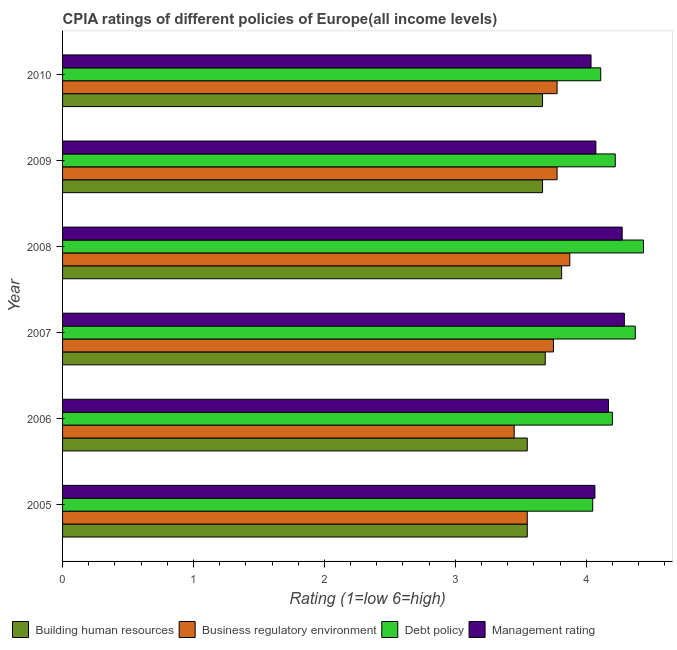How many groups of bars are there?
Offer a very short reply. 6. Are the number of bars per tick equal to the number of legend labels?
Make the answer very short. Yes. Are the number of bars on each tick of the Y-axis equal?
Your response must be concise. Yes. How many bars are there on the 5th tick from the top?
Ensure brevity in your answer.  4. How many bars are there on the 5th tick from the bottom?
Keep it short and to the point. 4. In how many cases, is the number of bars for a given year not equal to the number of legend labels?
Provide a succinct answer. 0. What is the cpia rating of debt policy in 2007?
Give a very brief answer. 4.38. Across all years, what is the maximum cpia rating of debt policy?
Make the answer very short. 4.44. Across all years, what is the minimum cpia rating of debt policy?
Keep it short and to the point. 4.05. In which year was the cpia rating of management maximum?
Provide a succinct answer. 2007. In which year was the cpia rating of management minimum?
Your answer should be very brief. 2010. What is the total cpia rating of building human resources in the graph?
Keep it short and to the point. 21.93. What is the difference between the cpia rating of debt policy in 2006 and that in 2008?
Provide a succinct answer. -0.24. What is the difference between the cpia rating of business regulatory environment in 2007 and the cpia rating of building human resources in 2005?
Give a very brief answer. 0.2. What is the average cpia rating of business regulatory environment per year?
Keep it short and to the point. 3.7. What is the ratio of the cpia rating of debt policy in 2006 to that in 2008?
Provide a short and direct response. 0.95. Is the cpia rating of debt policy in 2006 less than that in 2007?
Provide a succinct answer. Yes. Is the difference between the cpia rating of debt policy in 2005 and 2008 greater than the difference between the cpia rating of building human resources in 2005 and 2008?
Ensure brevity in your answer.  No. What is the difference between the highest and the second highest cpia rating of management?
Provide a short and direct response. 0.02. What is the difference between the highest and the lowest cpia rating of business regulatory environment?
Your answer should be compact. 0.42. In how many years, is the cpia rating of business regulatory environment greater than the average cpia rating of business regulatory environment taken over all years?
Offer a very short reply. 4. Is the sum of the cpia rating of management in 2007 and 2009 greater than the maximum cpia rating of debt policy across all years?
Offer a very short reply. Yes. What does the 2nd bar from the top in 2006 represents?
Keep it short and to the point. Debt policy. What does the 1st bar from the bottom in 2005 represents?
Ensure brevity in your answer.  Building human resources. Is it the case that in every year, the sum of the cpia rating of building human resources and cpia rating of business regulatory environment is greater than the cpia rating of debt policy?
Give a very brief answer. Yes. Are all the bars in the graph horizontal?
Make the answer very short. Yes. How many years are there in the graph?
Ensure brevity in your answer.  6. What is the title of the graph?
Provide a succinct answer. CPIA ratings of different policies of Europe(all income levels). Does "Austria" appear as one of the legend labels in the graph?
Make the answer very short. No. What is the label or title of the X-axis?
Give a very brief answer. Rating (1=low 6=high). What is the label or title of the Y-axis?
Provide a succinct answer. Year. What is the Rating (1=low 6=high) in Building human resources in 2005?
Ensure brevity in your answer.  3.55. What is the Rating (1=low 6=high) in Business regulatory environment in 2005?
Your answer should be very brief. 3.55. What is the Rating (1=low 6=high) of Debt policy in 2005?
Offer a very short reply. 4.05. What is the Rating (1=low 6=high) in Management rating in 2005?
Your response must be concise. 4.07. What is the Rating (1=low 6=high) in Building human resources in 2006?
Your answer should be very brief. 3.55. What is the Rating (1=low 6=high) of Business regulatory environment in 2006?
Offer a terse response. 3.45. What is the Rating (1=low 6=high) in Debt policy in 2006?
Give a very brief answer. 4.2. What is the Rating (1=low 6=high) of Management rating in 2006?
Provide a succinct answer. 4.17. What is the Rating (1=low 6=high) of Building human resources in 2007?
Provide a succinct answer. 3.69. What is the Rating (1=low 6=high) of Business regulatory environment in 2007?
Ensure brevity in your answer.  3.75. What is the Rating (1=low 6=high) of Debt policy in 2007?
Give a very brief answer. 4.38. What is the Rating (1=low 6=high) in Management rating in 2007?
Offer a terse response. 4.29. What is the Rating (1=low 6=high) in Building human resources in 2008?
Ensure brevity in your answer.  3.81. What is the Rating (1=low 6=high) in Business regulatory environment in 2008?
Offer a very short reply. 3.88. What is the Rating (1=low 6=high) in Debt policy in 2008?
Your response must be concise. 4.44. What is the Rating (1=low 6=high) of Management rating in 2008?
Your answer should be compact. 4.28. What is the Rating (1=low 6=high) of Building human resources in 2009?
Keep it short and to the point. 3.67. What is the Rating (1=low 6=high) of Business regulatory environment in 2009?
Offer a terse response. 3.78. What is the Rating (1=low 6=high) in Debt policy in 2009?
Provide a succinct answer. 4.22. What is the Rating (1=low 6=high) in Management rating in 2009?
Give a very brief answer. 4.07. What is the Rating (1=low 6=high) of Building human resources in 2010?
Your answer should be very brief. 3.67. What is the Rating (1=low 6=high) in Business regulatory environment in 2010?
Keep it short and to the point. 3.78. What is the Rating (1=low 6=high) of Debt policy in 2010?
Your answer should be very brief. 4.11. What is the Rating (1=low 6=high) in Management rating in 2010?
Your answer should be compact. 4.04. Across all years, what is the maximum Rating (1=low 6=high) of Building human resources?
Offer a very short reply. 3.81. Across all years, what is the maximum Rating (1=low 6=high) in Business regulatory environment?
Make the answer very short. 3.88. Across all years, what is the maximum Rating (1=low 6=high) in Debt policy?
Offer a terse response. 4.44. Across all years, what is the maximum Rating (1=low 6=high) in Management rating?
Offer a terse response. 4.29. Across all years, what is the minimum Rating (1=low 6=high) in Building human resources?
Give a very brief answer. 3.55. Across all years, what is the minimum Rating (1=low 6=high) in Business regulatory environment?
Keep it short and to the point. 3.45. Across all years, what is the minimum Rating (1=low 6=high) in Debt policy?
Make the answer very short. 4.05. Across all years, what is the minimum Rating (1=low 6=high) in Management rating?
Ensure brevity in your answer.  4.04. What is the total Rating (1=low 6=high) of Building human resources in the graph?
Provide a succinct answer. 21.93. What is the total Rating (1=low 6=high) in Business regulatory environment in the graph?
Your response must be concise. 22.18. What is the total Rating (1=low 6=high) in Debt policy in the graph?
Your answer should be very brief. 25.4. What is the total Rating (1=low 6=high) of Management rating in the graph?
Give a very brief answer. 24.91. What is the difference between the Rating (1=low 6=high) in Building human resources in 2005 and that in 2006?
Your response must be concise. 0. What is the difference between the Rating (1=low 6=high) of Business regulatory environment in 2005 and that in 2006?
Give a very brief answer. 0.1. What is the difference between the Rating (1=low 6=high) in Debt policy in 2005 and that in 2006?
Provide a short and direct response. -0.15. What is the difference between the Rating (1=low 6=high) in Management rating in 2005 and that in 2006?
Your answer should be very brief. -0.1. What is the difference between the Rating (1=low 6=high) of Building human resources in 2005 and that in 2007?
Offer a terse response. -0.14. What is the difference between the Rating (1=low 6=high) of Business regulatory environment in 2005 and that in 2007?
Provide a succinct answer. -0.2. What is the difference between the Rating (1=low 6=high) of Debt policy in 2005 and that in 2007?
Provide a short and direct response. -0.33. What is the difference between the Rating (1=low 6=high) of Management rating in 2005 and that in 2007?
Offer a very short reply. -0.23. What is the difference between the Rating (1=low 6=high) in Building human resources in 2005 and that in 2008?
Ensure brevity in your answer.  -0.26. What is the difference between the Rating (1=low 6=high) of Business regulatory environment in 2005 and that in 2008?
Ensure brevity in your answer.  -0.33. What is the difference between the Rating (1=low 6=high) of Debt policy in 2005 and that in 2008?
Make the answer very short. -0.39. What is the difference between the Rating (1=low 6=high) of Management rating in 2005 and that in 2008?
Keep it short and to the point. -0.21. What is the difference between the Rating (1=low 6=high) of Building human resources in 2005 and that in 2009?
Offer a very short reply. -0.12. What is the difference between the Rating (1=low 6=high) in Business regulatory environment in 2005 and that in 2009?
Keep it short and to the point. -0.23. What is the difference between the Rating (1=low 6=high) of Debt policy in 2005 and that in 2009?
Your answer should be very brief. -0.17. What is the difference between the Rating (1=low 6=high) in Management rating in 2005 and that in 2009?
Offer a very short reply. -0.01. What is the difference between the Rating (1=low 6=high) in Building human resources in 2005 and that in 2010?
Make the answer very short. -0.12. What is the difference between the Rating (1=low 6=high) in Business regulatory environment in 2005 and that in 2010?
Give a very brief answer. -0.23. What is the difference between the Rating (1=low 6=high) of Debt policy in 2005 and that in 2010?
Make the answer very short. -0.06. What is the difference between the Rating (1=low 6=high) in Management rating in 2005 and that in 2010?
Provide a short and direct response. 0.03. What is the difference between the Rating (1=low 6=high) in Building human resources in 2006 and that in 2007?
Your answer should be compact. -0.14. What is the difference between the Rating (1=low 6=high) in Debt policy in 2006 and that in 2007?
Provide a succinct answer. -0.17. What is the difference between the Rating (1=low 6=high) of Management rating in 2006 and that in 2007?
Your answer should be very brief. -0.12. What is the difference between the Rating (1=low 6=high) in Building human resources in 2006 and that in 2008?
Offer a very short reply. -0.26. What is the difference between the Rating (1=low 6=high) of Business regulatory environment in 2006 and that in 2008?
Make the answer very short. -0.42. What is the difference between the Rating (1=low 6=high) of Debt policy in 2006 and that in 2008?
Give a very brief answer. -0.24. What is the difference between the Rating (1=low 6=high) of Management rating in 2006 and that in 2008?
Keep it short and to the point. -0.1. What is the difference between the Rating (1=low 6=high) of Building human resources in 2006 and that in 2009?
Ensure brevity in your answer.  -0.12. What is the difference between the Rating (1=low 6=high) of Business regulatory environment in 2006 and that in 2009?
Give a very brief answer. -0.33. What is the difference between the Rating (1=low 6=high) of Debt policy in 2006 and that in 2009?
Your answer should be very brief. -0.02. What is the difference between the Rating (1=low 6=high) of Management rating in 2006 and that in 2009?
Give a very brief answer. 0.1. What is the difference between the Rating (1=low 6=high) in Building human resources in 2006 and that in 2010?
Offer a very short reply. -0.12. What is the difference between the Rating (1=low 6=high) in Business regulatory environment in 2006 and that in 2010?
Provide a short and direct response. -0.33. What is the difference between the Rating (1=low 6=high) in Debt policy in 2006 and that in 2010?
Provide a succinct answer. 0.09. What is the difference between the Rating (1=low 6=high) of Management rating in 2006 and that in 2010?
Offer a very short reply. 0.13. What is the difference between the Rating (1=low 6=high) of Building human resources in 2007 and that in 2008?
Provide a succinct answer. -0.12. What is the difference between the Rating (1=low 6=high) of Business regulatory environment in 2007 and that in 2008?
Provide a succinct answer. -0.12. What is the difference between the Rating (1=low 6=high) in Debt policy in 2007 and that in 2008?
Make the answer very short. -0.06. What is the difference between the Rating (1=low 6=high) of Management rating in 2007 and that in 2008?
Keep it short and to the point. 0.02. What is the difference between the Rating (1=low 6=high) of Building human resources in 2007 and that in 2009?
Provide a succinct answer. 0.02. What is the difference between the Rating (1=low 6=high) in Business regulatory environment in 2007 and that in 2009?
Ensure brevity in your answer.  -0.03. What is the difference between the Rating (1=low 6=high) in Debt policy in 2007 and that in 2009?
Provide a short and direct response. 0.15. What is the difference between the Rating (1=low 6=high) of Management rating in 2007 and that in 2009?
Offer a very short reply. 0.22. What is the difference between the Rating (1=low 6=high) in Building human resources in 2007 and that in 2010?
Your response must be concise. 0.02. What is the difference between the Rating (1=low 6=high) in Business regulatory environment in 2007 and that in 2010?
Make the answer very short. -0.03. What is the difference between the Rating (1=low 6=high) of Debt policy in 2007 and that in 2010?
Your answer should be very brief. 0.26. What is the difference between the Rating (1=low 6=high) of Management rating in 2007 and that in 2010?
Your response must be concise. 0.25. What is the difference between the Rating (1=low 6=high) of Building human resources in 2008 and that in 2009?
Keep it short and to the point. 0.15. What is the difference between the Rating (1=low 6=high) of Business regulatory environment in 2008 and that in 2009?
Your answer should be very brief. 0.1. What is the difference between the Rating (1=low 6=high) of Debt policy in 2008 and that in 2009?
Ensure brevity in your answer.  0.22. What is the difference between the Rating (1=low 6=high) in Management rating in 2008 and that in 2009?
Offer a very short reply. 0.2. What is the difference between the Rating (1=low 6=high) in Building human resources in 2008 and that in 2010?
Your answer should be compact. 0.15. What is the difference between the Rating (1=low 6=high) of Business regulatory environment in 2008 and that in 2010?
Give a very brief answer. 0.1. What is the difference between the Rating (1=low 6=high) of Debt policy in 2008 and that in 2010?
Offer a very short reply. 0.33. What is the difference between the Rating (1=low 6=high) in Management rating in 2008 and that in 2010?
Ensure brevity in your answer.  0.24. What is the difference between the Rating (1=low 6=high) of Building human resources in 2009 and that in 2010?
Ensure brevity in your answer.  0. What is the difference between the Rating (1=low 6=high) of Business regulatory environment in 2009 and that in 2010?
Provide a short and direct response. 0. What is the difference between the Rating (1=low 6=high) in Management rating in 2009 and that in 2010?
Your answer should be compact. 0.04. What is the difference between the Rating (1=low 6=high) of Building human resources in 2005 and the Rating (1=low 6=high) of Business regulatory environment in 2006?
Offer a very short reply. 0.1. What is the difference between the Rating (1=low 6=high) of Building human resources in 2005 and the Rating (1=low 6=high) of Debt policy in 2006?
Give a very brief answer. -0.65. What is the difference between the Rating (1=low 6=high) of Building human resources in 2005 and the Rating (1=low 6=high) of Management rating in 2006?
Your answer should be very brief. -0.62. What is the difference between the Rating (1=low 6=high) of Business regulatory environment in 2005 and the Rating (1=low 6=high) of Debt policy in 2006?
Offer a very short reply. -0.65. What is the difference between the Rating (1=low 6=high) in Business regulatory environment in 2005 and the Rating (1=low 6=high) in Management rating in 2006?
Make the answer very short. -0.62. What is the difference between the Rating (1=low 6=high) in Debt policy in 2005 and the Rating (1=low 6=high) in Management rating in 2006?
Your response must be concise. -0.12. What is the difference between the Rating (1=low 6=high) of Building human resources in 2005 and the Rating (1=low 6=high) of Business regulatory environment in 2007?
Make the answer very short. -0.2. What is the difference between the Rating (1=low 6=high) of Building human resources in 2005 and the Rating (1=low 6=high) of Debt policy in 2007?
Give a very brief answer. -0.82. What is the difference between the Rating (1=low 6=high) in Building human resources in 2005 and the Rating (1=low 6=high) in Management rating in 2007?
Give a very brief answer. -0.74. What is the difference between the Rating (1=low 6=high) of Business regulatory environment in 2005 and the Rating (1=low 6=high) of Debt policy in 2007?
Offer a very short reply. -0.82. What is the difference between the Rating (1=low 6=high) in Business regulatory environment in 2005 and the Rating (1=low 6=high) in Management rating in 2007?
Offer a very short reply. -0.74. What is the difference between the Rating (1=low 6=high) in Debt policy in 2005 and the Rating (1=low 6=high) in Management rating in 2007?
Offer a terse response. -0.24. What is the difference between the Rating (1=low 6=high) in Building human resources in 2005 and the Rating (1=low 6=high) in Business regulatory environment in 2008?
Offer a very short reply. -0.33. What is the difference between the Rating (1=low 6=high) in Building human resources in 2005 and the Rating (1=low 6=high) in Debt policy in 2008?
Your answer should be very brief. -0.89. What is the difference between the Rating (1=low 6=high) in Building human resources in 2005 and the Rating (1=low 6=high) in Management rating in 2008?
Keep it short and to the point. -0.72. What is the difference between the Rating (1=low 6=high) of Business regulatory environment in 2005 and the Rating (1=low 6=high) of Debt policy in 2008?
Offer a very short reply. -0.89. What is the difference between the Rating (1=low 6=high) in Business regulatory environment in 2005 and the Rating (1=low 6=high) in Management rating in 2008?
Your answer should be compact. -0.72. What is the difference between the Rating (1=low 6=high) in Debt policy in 2005 and the Rating (1=low 6=high) in Management rating in 2008?
Your response must be concise. -0.23. What is the difference between the Rating (1=low 6=high) of Building human resources in 2005 and the Rating (1=low 6=high) of Business regulatory environment in 2009?
Make the answer very short. -0.23. What is the difference between the Rating (1=low 6=high) of Building human resources in 2005 and the Rating (1=low 6=high) of Debt policy in 2009?
Give a very brief answer. -0.67. What is the difference between the Rating (1=low 6=high) of Building human resources in 2005 and the Rating (1=low 6=high) of Management rating in 2009?
Give a very brief answer. -0.52. What is the difference between the Rating (1=low 6=high) of Business regulatory environment in 2005 and the Rating (1=low 6=high) of Debt policy in 2009?
Offer a very short reply. -0.67. What is the difference between the Rating (1=low 6=high) in Business regulatory environment in 2005 and the Rating (1=low 6=high) in Management rating in 2009?
Offer a terse response. -0.52. What is the difference between the Rating (1=low 6=high) of Debt policy in 2005 and the Rating (1=low 6=high) of Management rating in 2009?
Ensure brevity in your answer.  -0.02. What is the difference between the Rating (1=low 6=high) in Building human resources in 2005 and the Rating (1=low 6=high) in Business regulatory environment in 2010?
Offer a very short reply. -0.23. What is the difference between the Rating (1=low 6=high) in Building human resources in 2005 and the Rating (1=low 6=high) in Debt policy in 2010?
Give a very brief answer. -0.56. What is the difference between the Rating (1=low 6=high) in Building human resources in 2005 and the Rating (1=low 6=high) in Management rating in 2010?
Give a very brief answer. -0.49. What is the difference between the Rating (1=low 6=high) in Business regulatory environment in 2005 and the Rating (1=low 6=high) in Debt policy in 2010?
Keep it short and to the point. -0.56. What is the difference between the Rating (1=low 6=high) of Business regulatory environment in 2005 and the Rating (1=low 6=high) of Management rating in 2010?
Provide a succinct answer. -0.49. What is the difference between the Rating (1=low 6=high) in Debt policy in 2005 and the Rating (1=low 6=high) in Management rating in 2010?
Your answer should be very brief. 0.01. What is the difference between the Rating (1=low 6=high) of Building human resources in 2006 and the Rating (1=low 6=high) of Business regulatory environment in 2007?
Your answer should be compact. -0.2. What is the difference between the Rating (1=low 6=high) of Building human resources in 2006 and the Rating (1=low 6=high) of Debt policy in 2007?
Your answer should be compact. -0.82. What is the difference between the Rating (1=low 6=high) of Building human resources in 2006 and the Rating (1=low 6=high) of Management rating in 2007?
Ensure brevity in your answer.  -0.74. What is the difference between the Rating (1=low 6=high) in Business regulatory environment in 2006 and the Rating (1=low 6=high) in Debt policy in 2007?
Ensure brevity in your answer.  -0.93. What is the difference between the Rating (1=low 6=high) of Business regulatory environment in 2006 and the Rating (1=low 6=high) of Management rating in 2007?
Offer a very short reply. -0.84. What is the difference between the Rating (1=low 6=high) in Debt policy in 2006 and the Rating (1=low 6=high) in Management rating in 2007?
Provide a succinct answer. -0.09. What is the difference between the Rating (1=low 6=high) of Building human resources in 2006 and the Rating (1=low 6=high) of Business regulatory environment in 2008?
Your answer should be compact. -0.33. What is the difference between the Rating (1=low 6=high) in Building human resources in 2006 and the Rating (1=low 6=high) in Debt policy in 2008?
Your response must be concise. -0.89. What is the difference between the Rating (1=low 6=high) of Building human resources in 2006 and the Rating (1=low 6=high) of Management rating in 2008?
Your answer should be compact. -0.72. What is the difference between the Rating (1=low 6=high) of Business regulatory environment in 2006 and the Rating (1=low 6=high) of Debt policy in 2008?
Your answer should be very brief. -0.99. What is the difference between the Rating (1=low 6=high) in Business regulatory environment in 2006 and the Rating (1=low 6=high) in Management rating in 2008?
Your answer should be very brief. -0.82. What is the difference between the Rating (1=low 6=high) of Debt policy in 2006 and the Rating (1=low 6=high) of Management rating in 2008?
Provide a succinct answer. -0.07. What is the difference between the Rating (1=low 6=high) in Building human resources in 2006 and the Rating (1=low 6=high) in Business regulatory environment in 2009?
Offer a very short reply. -0.23. What is the difference between the Rating (1=low 6=high) of Building human resources in 2006 and the Rating (1=low 6=high) of Debt policy in 2009?
Make the answer very short. -0.67. What is the difference between the Rating (1=low 6=high) in Building human resources in 2006 and the Rating (1=low 6=high) in Management rating in 2009?
Provide a short and direct response. -0.52. What is the difference between the Rating (1=low 6=high) in Business regulatory environment in 2006 and the Rating (1=low 6=high) in Debt policy in 2009?
Keep it short and to the point. -0.77. What is the difference between the Rating (1=low 6=high) in Business regulatory environment in 2006 and the Rating (1=low 6=high) in Management rating in 2009?
Ensure brevity in your answer.  -0.62. What is the difference between the Rating (1=low 6=high) in Debt policy in 2006 and the Rating (1=low 6=high) in Management rating in 2009?
Make the answer very short. 0.13. What is the difference between the Rating (1=low 6=high) of Building human resources in 2006 and the Rating (1=low 6=high) of Business regulatory environment in 2010?
Offer a terse response. -0.23. What is the difference between the Rating (1=low 6=high) of Building human resources in 2006 and the Rating (1=low 6=high) of Debt policy in 2010?
Your answer should be very brief. -0.56. What is the difference between the Rating (1=low 6=high) in Building human resources in 2006 and the Rating (1=low 6=high) in Management rating in 2010?
Your answer should be compact. -0.49. What is the difference between the Rating (1=low 6=high) in Business regulatory environment in 2006 and the Rating (1=low 6=high) in Debt policy in 2010?
Keep it short and to the point. -0.66. What is the difference between the Rating (1=low 6=high) of Business regulatory environment in 2006 and the Rating (1=low 6=high) of Management rating in 2010?
Provide a succinct answer. -0.59. What is the difference between the Rating (1=low 6=high) in Debt policy in 2006 and the Rating (1=low 6=high) in Management rating in 2010?
Your answer should be compact. 0.16. What is the difference between the Rating (1=low 6=high) of Building human resources in 2007 and the Rating (1=low 6=high) of Business regulatory environment in 2008?
Keep it short and to the point. -0.19. What is the difference between the Rating (1=low 6=high) of Building human resources in 2007 and the Rating (1=low 6=high) of Debt policy in 2008?
Keep it short and to the point. -0.75. What is the difference between the Rating (1=low 6=high) in Building human resources in 2007 and the Rating (1=low 6=high) in Management rating in 2008?
Ensure brevity in your answer.  -0.59. What is the difference between the Rating (1=low 6=high) in Business regulatory environment in 2007 and the Rating (1=low 6=high) in Debt policy in 2008?
Ensure brevity in your answer.  -0.69. What is the difference between the Rating (1=low 6=high) in Business regulatory environment in 2007 and the Rating (1=low 6=high) in Management rating in 2008?
Your response must be concise. -0.53. What is the difference between the Rating (1=low 6=high) of Debt policy in 2007 and the Rating (1=low 6=high) of Management rating in 2008?
Your answer should be very brief. 0.1. What is the difference between the Rating (1=low 6=high) of Building human resources in 2007 and the Rating (1=low 6=high) of Business regulatory environment in 2009?
Offer a very short reply. -0.09. What is the difference between the Rating (1=low 6=high) of Building human resources in 2007 and the Rating (1=low 6=high) of Debt policy in 2009?
Your answer should be very brief. -0.53. What is the difference between the Rating (1=low 6=high) of Building human resources in 2007 and the Rating (1=low 6=high) of Management rating in 2009?
Provide a succinct answer. -0.39. What is the difference between the Rating (1=low 6=high) in Business regulatory environment in 2007 and the Rating (1=low 6=high) in Debt policy in 2009?
Provide a short and direct response. -0.47. What is the difference between the Rating (1=low 6=high) of Business regulatory environment in 2007 and the Rating (1=low 6=high) of Management rating in 2009?
Provide a short and direct response. -0.32. What is the difference between the Rating (1=low 6=high) of Debt policy in 2007 and the Rating (1=low 6=high) of Management rating in 2009?
Your answer should be compact. 0.3. What is the difference between the Rating (1=low 6=high) in Building human resources in 2007 and the Rating (1=low 6=high) in Business regulatory environment in 2010?
Your response must be concise. -0.09. What is the difference between the Rating (1=low 6=high) of Building human resources in 2007 and the Rating (1=low 6=high) of Debt policy in 2010?
Make the answer very short. -0.42. What is the difference between the Rating (1=low 6=high) in Building human resources in 2007 and the Rating (1=low 6=high) in Management rating in 2010?
Keep it short and to the point. -0.35. What is the difference between the Rating (1=low 6=high) in Business regulatory environment in 2007 and the Rating (1=low 6=high) in Debt policy in 2010?
Offer a very short reply. -0.36. What is the difference between the Rating (1=low 6=high) in Business regulatory environment in 2007 and the Rating (1=low 6=high) in Management rating in 2010?
Provide a short and direct response. -0.29. What is the difference between the Rating (1=low 6=high) in Debt policy in 2007 and the Rating (1=low 6=high) in Management rating in 2010?
Your answer should be very brief. 0.34. What is the difference between the Rating (1=low 6=high) in Building human resources in 2008 and the Rating (1=low 6=high) in Business regulatory environment in 2009?
Offer a terse response. 0.03. What is the difference between the Rating (1=low 6=high) in Building human resources in 2008 and the Rating (1=low 6=high) in Debt policy in 2009?
Your response must be concise. -0.41. What is the difference between the Rating (1=low 6=high) in Building human resources in 2008 and the Rating (1=low 6=high) in Management rating in 2009?
Provide a succinct answer. -0.26. What is the difference between the Rating (1=low 6=high) of Business regulatory environment in 2008 and the Rating (1=low 6=high) of Debt policy in 2009?
Offer a very short reply. -0.35. What is the difference between the Rating (1=low 6=high) in Business regulatory environment in 2008 and the Rating (1=low 6=high) in Management rating in 2009?
Offer a terse response. -0.2. What is the difference between the Rating (1=low 6=high) of Debt policy in 2008 and the Rating (1=low 6=high) of Management rating in 2009?
Offer a terse response. 0.36. What is the difference between the Rating (1=low 6=high) of Building human resources in 2008 and the Rating (1=low 6=high) of Business regulatory environment in 2010?
Provide a succinct answer. 0.03. What is the difference between the Rating (1=low 6=high) of Building human resources in 2008 and the Rating (1=low 6=high) of Debt policy in 2010?
Your answer should be very brief. -0.3. What is the difference between the Rating (1=low 6=high) in Building human resources in 2008 and the Rating (1=low 6=high) in Management rating in 2010?
Provide a succinct answer. -0.22. What is the difference between the Rating (1=low 6=high) of Business regulatory environment in 2008 and the Rating (1=low 6=high) of Debt policy in 2010?
Your answer should be very brief. -0.24. What is the difference between the Rating (1=low 6=high) in Business regulatory environment in 2008 and the Rating (1=low 6=high) in Management rating in 2010?
Provide a short and direct response. -0.16. What is the difference between the Rating (1=low 6=high) in Debt policy in 2008 and the Rating (1=low 6=high) in Management rating in 2010?
Your answer should be very brief. 0.4. What is the difference between the Rating (1=low 6=high) in Building human resources in 2009 and the Rating (1=low 6=high) in Business regulatory environment in 2010?
Offer a very short reply. -0.11. What is the difference between the Rating (1=low 6=high) in Building human resources in 2009 and the Rating (1=low 6=high) in Debt policy in 2010?
Provide a succinct answer. -0.44. What is the difference between the Rating (1=low 6=high) of Building human resources in 2009 and the Rating (1=low 6=high) of Management rating in 2010?
Offer a very short reply. -0.37. What is the difference between the Rating (1=low 6=high) in Business regulatory environment in 2009 and the Rating (1=low 6=high) in Management rating in 2010?
Provide a short and direct response. -0.26. What is the difference between the Rating (1=low 6=high) of Debt policy in 2009 and the Rating (1=low 6=high) of Management rating in 2010?
Keep it short and to the point. 0.19. What is the average Rating (1=low 6=high) in Building human resources per year?
Ensure brevity in your answer.  3.66. What is the average Rating (1=low 6=high) of Business regulatory environment per year?
Keep it short and to the point. 3.7. What is the average Rating (1=low 6=high) of Debt policy per year?
Offer a terse response. 4.23. What is the average Rating (1=low 6=high) in Management rating per year?
Provide a succinct answer. 4.15. In the year 2005, what is the difference between the Rating (1=low 6=high) in Building human resources and Rating (1=low 6=high) in Business regulatory environment?
Provide a succinct answer. 0. In the year 2005, what is the difference between the Rating (1=low 6=high) of Building human resources and Rating (1=low 6=high) of Debt policy?
Offer a very short reply. -0.5. In the year 2005, what is the difference between the Rating (1=low 6=high) in Building human resources and Rating (1=low 6=high) in Management rating?
Make the answer very short. -0.52. In the year 2005, what is the difference between the Rating (1=low 6=high) of Business regulatory environment and Rating (1=low 6=high) of Debt policy?
Provide a short and direct response. -0.5. In the year 2005, what is the difference between the Rating (1=low 6=high) in Business regulatory environment and Rating (1=low 6=high) in Management rating?
Provide a succinct answer. -0.52. In the year 2005, what is the difference between the Rating (1=low 6=high) of Debt policy and Rating (1=low 6=high) of Management rating?
Make the answer very short. -0.02. In the year 2006, what is the difference between the Rating (1=low 6=high) of Building human resources and Rating (1=low 6=high) of Business regulatory environment?
Make the answer very short. 0.1. In the year 2006, what is the difference between the Rating (1=low 6=high) of Building human resources and Rating (1=low 6=high) of Debt policy?
Ensure brevity in your answer.  -0.65. In the year 2006, what is the difference between the Rating (1=low 6=high) of Building human resources and Rating (1=low 6=high) of Management rating?
Make the answer very short. -0.62. In the year 2006, what is the difference between the Rating (1=low 6=high) of Business regulatory environment and Rating (1=low 6=high) of Debt policy?
Your answer should be very brief. -0.75. In the year 2006, what is the difference between the Rating (1=low 6=high) of Business regulatory environment and Rating (1=low 6=high) of Management rating?
Provide a succinct answer. -0.72. In the year 2006, what is the difference between the Rating (1=low 6=high) of Debt policy and Rating (1=low 6=high) of Management rating?
Your response must be concise. 0.03. In the year 2007, what is the difference between the Rating (1=low 6=high) of Building human resources and Rating (1=low 6=high) of Business regulatory environment?
Ensure brevity in your answer.  -0.06. In the year 2007, what is the difference between the Rating (1=low 6=high) in Building human resources and Rating (1=low 6=high) in Debt policy?
Offer a very short reply. -0.69. In the year 2007, what is the difference between the Rating (1=low 6=high) of Building human resources and Rating (1=low 6=high) of Management rating?
Your answer should be very brief. -0.6. In the year 2007, what is the difference between the Rating (1=low 6=high) of Business regulatory environment and Rating (1=low 6=high) of Debt policy?
Offer a very short reply. -0.62. In the year 2007, what is the difference between the Rating (1=low 6=high) of Business regulatory environment and Rating (1=low 6=high) of Management rating?
Give a very brief answer. -0.54. In the year 2007, what is the difference between the Rating (1=low 6=high) of Debt policy and Rating (1=low 6=high) of Management rating?
Keep it short and to the point. 0.08. In the year 2008, what is the difference between the Rating (1=low 6=high) of Building human resources and Rating (1=low 6=high) of Business regulatory environment?
Offer a terse response. -0.06. In the year 2008, what is the difference between the Rating (1=low 6=high) in Building human resources and Rating (1=low 6=high) in Debt policy?
Provide a succinct answer. -0.62. In the year 2008, what is the difference between the Rating (1=low 6=high) of Building human resources and Rating (1=low 6=high) of Management rating?
Give a very brief answer. -0.46. In the year 2008, what is the difference between the Rating (1=low 6=high) of Business regulatory environment and Rating (1=low 6=high) of Debt policy?
Give a very brief answer. -0.56. In the year 2008, what is the difference between the Rating (1=low 6=high) in Debt policy and Rating (1=low 6=high) in Management rating?
Your answer should be compact. 0.16. In the year 2009, what is the difference between the Rating (1=low 6=high) in Building human resources and Rating (1=low 6=high) in Business regulatory environment?
Offer a very short reply. -0.11. In the year 2009, what is the difference between the Rating (1=low 6=high) of Building human resources and Rating (1=low 6=high) of Debt policy?
Provide a short and direct response. -0.56. In the year 2009, what is the difference between the Rating (1=low 6=high) of Building human resources and Rating (1=low 6=high) of Management rating?
Your response must be concise. -0.41. In the year 2009, what is the difference between the Rating (1=low 6=high) of Business regulatory environment and Rating (1=low 6=high) of Debt policy?
Provide a succinct answer. -0.44. In the year 2009, what is the difference between the Rating (1=low 6=high) in Business regulatory environment and Rating (1=low 6=high) in Management rating?
Make the answer very short. -0.3. In the year 2009, what is the difference between the Rating (1=low 6=high) of Debt policy and Rating (1=low 6=high) of Management rating?
Offer a terse response. 0.15. In the year 2010, what is the difference between the Rating (1=low 6=high) of Building human resources and Rating (1=low 6=high) of Business regulatory environment?
Offer a very short reply. -0.11. In the year 2010, what is the difference between the Rating (1=low 6=high) in Building human resources and Rating (1=low 6=high) in Debt policy?
Your answer should be very brief. -0.44. In the year 2010, what is the difference between the Rating (1=low 6=high) of Building human resources and Rating (1=low 6=high) of Management rating?
Offer a very short reply. -0.37. In the year 2010, what is the difference between the Rating (1=low 6=high) of Business regulatory environment and Rating (1=low 6=high) of Management rating?
Offer a very short reply. -0.26. In the year 2010, what is the difference between the Rating (1=low 6=high) of Debt policy and Rating (1=low 6=high) of Management rating?
Your answer should be very brief. 0.07. What is the ratio of the Rating (1=low 6=high) in Business regulatory environment in 2005 to that in 2006?
Your response must be concise. 1.03. What is the ratio of the Rating (1=low 6=high) in Management rating in 2005 to that in 2006?
Keep it short and to the point. 0.98. What is the ratio of the Rating (1=low 6=high) of Building human resources in 2005 to that in 2007?
Your answer should be very brief. 0.96. What is the ratio of the Rating (1=low 6=high) in Business regulatory environment in 2005 to that in 2007?
Keep it short and to the point. 0.95. What is the ratio of the Rating (1=low 6=high) in Debt policy in 2005 to that in 2007?
Keep it short and to the point. 0.93. What is the ratio of the Rating (1=low 6=high) of Management rating in 2005 to that in 2007?
Ensure brevity in your answer.  0.95. What is the ratio of the Rating (1=low 6=high) in Building human resources in 2005 to that in 2008?
Your answer should be very brief. 0.93. What is the ratio of the Rating (1=low 6=high) of Business regulatory environment in 2005 to that in 2008?
Your response must be concise. 0.92. What is the ratio of the Rating (1=low 6=high) in Debt policy in 2005 to that in 2008?
Keep it short and to the point. 0.91. What is the ratio of the Rating (1=low 6=high) in Management rating in 2005 to that in 2008?
Offer a terse response. 0.95. What is the ratio of the Rating (1=low 6=high) of Building human resources in 2005 to that in 2009?
Your response must be concise. 0.97. What is the ratio of the Rating (1=low 6=high) in Business regulatory environment in 2005 to that in 2009?
Provide a succinct answer. 0.94. What is the ratio of the Rating (1=low 6=high) in Debt policy in 2005 to that in 2009?
Your answer should be very brief. 0.96. What is the ratio of the Rating (1=low 6=high) in Management rating in 2005 to that in 2009?
Provide a short and direct response. 1. What is the ratio of the Rating (1=low 6=high) of Building human resources in 2005 to that in 2010?
Make the answer very short. 0.97. What is the ratio of the Rating (1=low 6=high) of Business regulatory environment in 2005 to that in 2010?
Offer a terse response. 0.94. What is the ratio of the Rating (1=low 6=high) in Debt policy in 2005 to that in 2010?
Your answer should be very brief. 0.99. What is the ratio of the Rating (1=low 6=high) of Management rating in 2005 to that in 2010?
Make the answer very short. 1.01. What is the ratio of the Rating (1=low 6=high) of Building human resources in 2006 to that in 2007?
Make the answer very short. 0.96. What is the ratio of the Rating (1=low 6=high) of Business regulatory environment in 2006 to that in 2007?
Provide a short and direct response. 0.92. What is the ratio of the Rating (1=low 6=high) in Debt policy in 2006 to that in 2007?
Make the answer very short. 0.96. What is the ratio of the Rating (1=low 6=high) of Management rating in 2006 to that in 2007?
Keep it short and to the point. 0.97. What is the ratio of the Rating (1=low 6=high) in Building human resources in 2006 to that in 2008?
Offer a very short reply. 0.93. What is the ratio of the Rating (1=low 6=high) of Business regulatory environment in 2006 to that in 2008?
Keep it short and to the point. 0.89. What is the ratio of the Rating (1=low 6=high) in Debt policy in 2006 to that in 2008?
Provide a short and direct response. 0.95. What is the ratio of the Rating (1=low 6=high) of Management rating in 2006 to that in 2008?
Your response must be concise. 0.98. What is the ratio of the Rating (1=low 6=high) of Building human resources in 2006 to that in 2009?
Your answer should be compact. 0.97. What is the ratio of the Rating (1=low 6=high) in Business regulatory environment in 2006 to that in 2009?
Make the answer very short. 0.91. What is the ratio of the Rating (1=low 6=high) in Management rating in 2006 to that in 2009?
Give a very brief answer. 1.02. What is the ratio of the Rating (1=low 6=high) in Building human resources in 2006 to that in 2010?
Your response must be concise. 0.97. What is the ratio of the Rating (1=low 6=high) in Business regulatory environment in 2006 to that in 2010?
Ensure brevity in your answer.  0.91. What is the ratio of the Rating (1=low 6=high) in Debt policy in 2006 to that in 2010?
Provide a succinct answer. 1.02. What is the ratio of the Rating (1=low 6=high) of Management rating in 2006 to that in 2010?
Offer a terse response. 1.03. What is the ratio of the Rating (1=low 6=high) in Building human resources in 2007 to that in 2008?
Keep it short and to the point. 0.97. What is the ratio of the Rating (1=low 6=high) in Debt policy in 2007 to that in 2008?
Provide a succinct answer. 0.99. What is the ratio of the Rating (1=low 6=high) of Building human resources in 2007 to that in 2009?
Make the answer very short. 1.01. What is the ratio of the Rating (1=low 6=high) of Debt policy in 2007 to that in 2009?
Give a very brief answer. 1.04. What is the ratio of the Rating (1=low 6=high) of Management rating in 2007 to that in 2009?
Your response must be concise. 1.05. What is the ratio of the Rating (1=low 6=high) of Business regulatory environment in 2007 to that in 2010?
Provide a short and direct response. 0.99. What is the ratio of the Rating (1=low 6=high) of Debt policy in 2007 to that in 2010?
Make the answer very short. 1.06. What is the ratio of the Rating (1=low 6=high) in Management rating in 2007 to that in 2010?
Provide a succinct answer. 1.06. What is the ratio of the Rating (1=low 6=high) in Building human resources in 2008 to that in 2009?
Your answer should be compact. 1.04. What is the ratio of the Rating (1=low 6=high) of Business regulatory environment in 2008 to that in 2009?
Keep it short and to the point. 1.03. What is the ratio of the Rating (1=low 6=high) in Debt policy in 2008 to that in 2009?
Ensure brevity in your answer.  1.05. What is the ratio of the Rating (1=low 6=high) of Management rating in 2008 to that in 2009?
Provide a succinct answer. 1.05. What is the ratio of the Rating (1=low 6=high) in Building human resources in 2008 to that in 2010?
Ensure brevity in your answer.  1.04. What is the ratio of the Rating (1=low 6=high) of Business regulatory environment in 2008 to that in 2010?
Your answer should be compact. 1.03. What is the ratio of the Rating (1=low 6=high) of Debt policy in 2008 to that in 2010?
Offer a very short reply. 1.08. What is the ratio of the Rating (1=low 6=high) in Management rating in 2008 to that in 2010?
Make the answer very short. 1.06. What is the ratio of the Rating (1=low 6=high) of Building human resources in 2009 to that in 2010?
Your answer should be very brief. 1. What is the ratio of the Rating (1=low 6=high) in Management rating in 2009 to that in 2010?
Offer a terse response. 1.01. What is the difference between the highest and the second highest Rating (1=low 6=high) in Business regulatory environment?
Your response must be concise. 0.1. What is the difference between the highest and the second highest Rating (1=low 6=high) in Debt policy?
Your response must be concise. 0.06. What is the difference between the highest and the second highest Rating (1=low 6=high) of Management rating?
Offer a very short reply. 0.02. What is the difference between the highest and the lowest Rating (1=low 6=high) in Building human resources?
Your answer should be very brief. 0.26. What is the difference between the highest and the lowest Rating (1=low 6=high) of Business regulatory environment?
Ensure brevity in your answer.  0.42. What is the difference between the highest and the lowest Rating (1=low 6=high) in Debt policy?
Make the answer very short. 0.39. What is the difference between the highest and the lowest Rating (1=low 6=high) in Management rating?
Offer a terse response. 0.25. 